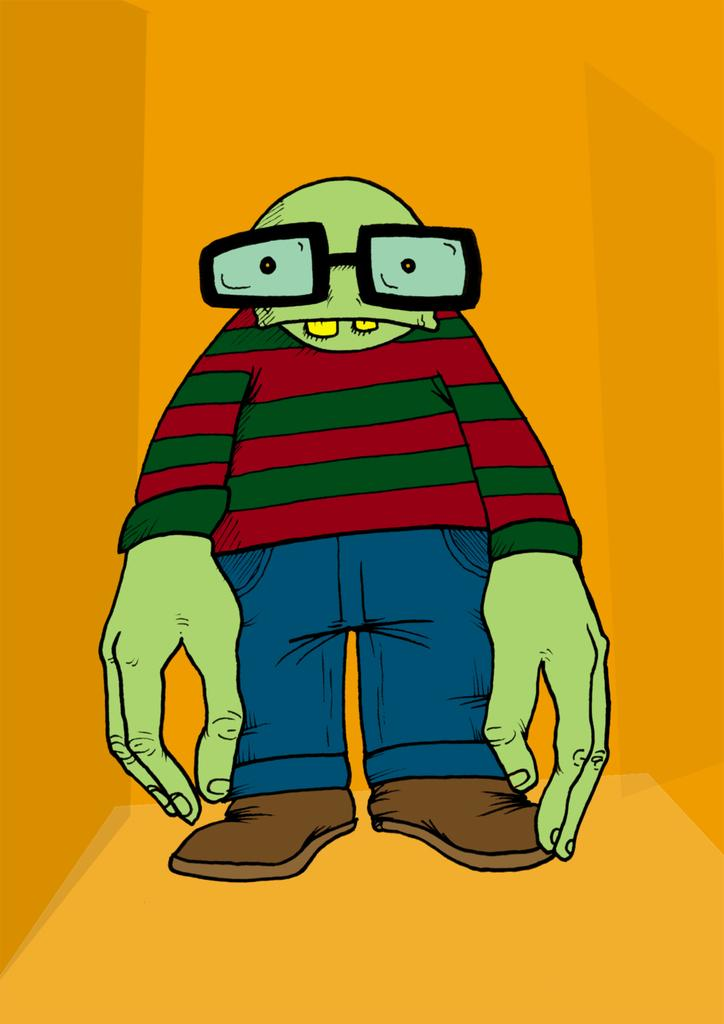What type of character is present in the image? There is a cartoon character in the image. What accessory can be seen on the cartoon character? There are spectacles in the image. What type of items are visible in the image related to personal appearance? There are clothes and footwears in the image. How many rats are present in the image? There are no rats present in the image. What type of farming equipment can be seen in the image? There is no farming equipment, such as a plough, present in the image. 